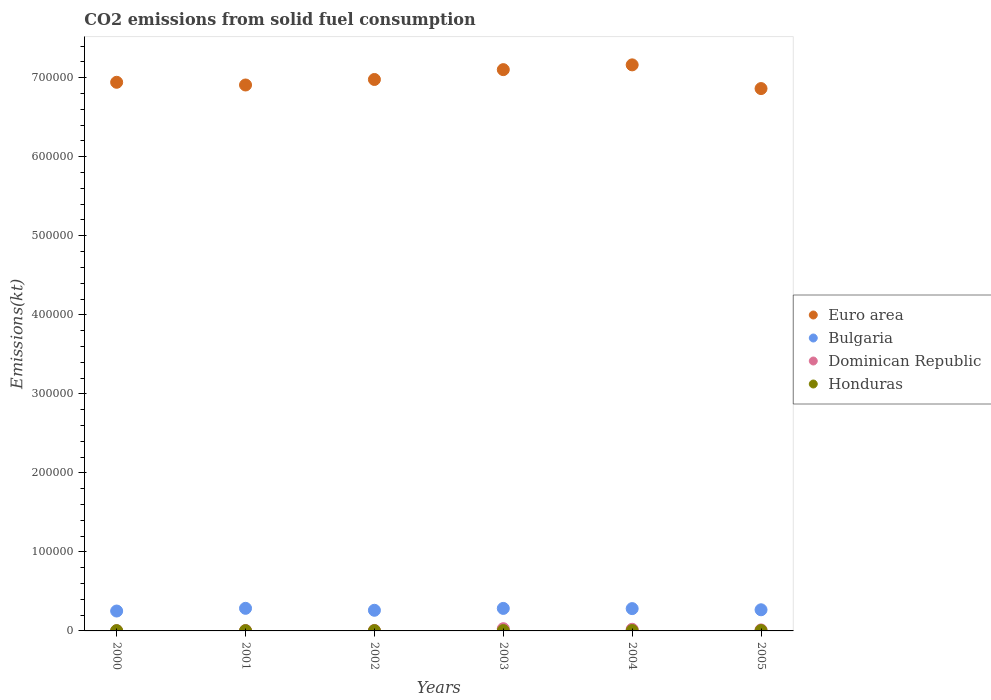What is the amount of CO2 emitted in Dominican Republic in 2000?
Provide a short and direct response. 245.69. Across all years, what is the maximum amount of CO2 emitted in Euro area?
Make the answer very short. 7.16e+05. Across all years, what is the minimum amount of CO2 emitted in Euro area?
Offer a very short reply. 6.86e+05. In which year was the amount of CO2 emitted in Dominican Republic minimum?
Offer a very short reply. 2000. What is the total amount of CO2 emitted in Bulgaria in the graph?
Ensure brevity in your answer.  1.63e+05. What is the difference between the amount of CO2 emitted in Euro area in 2000 and that in 2004?
Offer a very short reply. -2.20e+04. What is the difference between the amount of CO2 emitted in Bulgaria in 2004 and the amount of CO2 emitted in Honduras in 2001?
Offer a very short reply. 2.79e+04. What is the average amount of CO2 emitted in Honduras per year?
Make the answer very short. 409.48. In the year 2002, what is the difference between the amount of CO2 emitted in Honduras and amount of CO2 emitted in Dominican Republic?
Keep it short and to the point. -245.69. What is the ratio of the amount of CO2 emitted in Euro area in 2002 to that in 2003?
Offer a terse response. 0.98. Is the amount of CO2 emitted in Dominican Republic in 2001 less than that in 2005?
Keep it short and to the point. Yes. What is the difference between the highest and the second highest amount of CO2 emitted in Honduras?
Provide a short and direct response. 25.67. What is the difference between the highest and the lowest amount of CO2 emitted in Honduras?
Give a very brief answer. 161.35. Is the sum of the amount of CO2 emitted in Bulgaria in 2002 and 2004 greater than the maximum amount of CO2 emitted in Euro area across all years?
Give a very brief answer. No. Is it the case that in every year, the sum of the amount of CO2 emitted in Euro area and amount of CO2 emitted in Dominican Republic  is greater than the sum of amount of CO2 emitted in Bulgaria and amount of CO2 emitted in Honduras?
Your answer should be very brief. Yes. Does the amount of CO2 emitted in Bulgaria monotonically increase over the years?
Offer a very short reply. No. What is the difference between two consecutive major ticks on the Y-axis?
Make the answer very short. 1.00e+05. Are the values on the major ticks of Y-axis written in scientific E-notation?
Provide a short and direct response. No. Does the graph contain any zero values?
Your answer should be very brief. No. How many legend labels are there?
Make the answer very short. 4. What is the title of the graph?
Your answer should be very brief. CO2 emissions from solid fuel consumption. Does "United Kingdom" appear as one of the legend labels in the graph?
Ensure brevity in your answer.  No. What is the label or title of the Y-axis?
Your response must be concise. Emissions(kt). What is the Emissions(kt) of Euro area in 2000?
Provide a short and direct response. 6.94e+05. What is the Emissions(kt) of Bulgaria in 2000?
Ensure brevity in your answer.  2.52e+04. What is the Emissions(kt) of Dominican Republic in 2000?
Your answer should be compact. 245.69. What is the Emissions(kt) in Honduras in 2000?
Provide a short and direct response. 359.37. What is the Emissions(kt) of Euro area in 2001?
Offer a terse response. 6.91e+05. What is the Emissions(kt) in Bulgaria in 2001?
Offer a terse response. 2.86e+04. What is the Emissions(kt) of Dominican Republic in 2001?
Your answer should be very brief. 539.05. What is the Emissions(kt) in Honduras in 2001?
Keep it short and to the point. 326.36. What is the Emissions(kt) of Euro area in 2002?
Keep it short and to the point. 6.98e+05. What is the Emissions(kt) in Bulgaria in 2002?
Your response must be concise. 2.61e+04. What is the Emissions(kt) of Dominican Republic in 2002?
Your answer should be very brief. 619.72. What is the Emissions(kt) in Honduras in 2002?
Your answer should be compact. 374.03. What is the Emissions(kt) in Euro area in 2003?
Make the answer very short. 7.10e+05. What is the Emissions(kt) of Bulgaria in 2003?
Provide a short and direct response. 2.85e+04. What is the Emissions(kt) in Dominican Republic in 2003?
Your response must be concise. 2805.26. What is the Emissions(kt) of Honduras in 2003?
Offer a terse response. 447.37. What is the Emissions(kt) in Euro area in 2004?
Offer a very short reply. 7.16e+05. What is the Emissions(kt) of Bulgaria in 2004?
Offer a terse response. 2.82e+04. What is the Emissions(kt) in Dominican Republic in 2004?
Provide a succinct answer. 2064.52. What is the Emissions(kt) in Honduras in 2004?
Your answer should be compact. 462.04. What is the Emissions(kt) in Euro area in 2005?
Ensure brevity in your answer.  6.86e+05. What is the Emissions(kt) in Bulgaria in 2005?
Offer a terse response. 2.68e+04. What is the Emissions(kt) of Dominican Republic in 2005?
Offer a terse response. 1265.12. What is the Emissions(kt) of Honduras in 2005?
Your answer should be very brief. 487.71. Across all years, what is the maximum Emissions(kt) in Euro area?
Ensure brevity in your answer.  7.16e+05. Across all years, what is the maximum Emissions(kt) of Bulgaria?
Keep it short and to the point. 2.86e+04. Across all years, what is the maximum Emissions(kt) in Dominican Republic?
Give a very brief answer. 2805.26. Across all years, what is the maximum Emissions(kt) in Honduras?
Your answer should be compact. 487.71. Across all years, what is the minimum Emissions(kt) of Euro area?
Provide a succinct answer. 6.86e+05. Across all years, what is the minimum Emissions(kt) of Bulgaria?
Provide a short and direct response. 2.52e+04. Across all years, what is the minimum Emissions(kt) of Dominican Republic?
Give a very brief answer. 245.69. Across all years, what is the minimum Emissions(kt) of Honduras?
Make the answer very short. 326.36. What is the total Emissions(kt) in Euro area in the graph?
Provide a succinct answer. 4.20e+06. What is the total Emissions(kt) of Bulgaria in the graph?
Keep it short and to the point. 1.63e+05. What is the total Emissions(kt) of Dominican Republic in the graph?
Provide a short and direct response. 7539.35. What is the total Emissions(kt) of Honduras in the graph?
Offer a terse response. 2456.89. What is the difference between the Emissions(kt) in Euro area in 2000 and that in 2001?
Keep it short and to the point. 3419.57. What is the difference between the Emissions(kt) in Bulgaria in 2000 and that in 2001?
Provide a short and direct response. -3417.64. What is the difference between the Emissions(kt) of Dominican Republic in 2000 and that in 2001?
Ensure brevity in your answer.  -293.36. What is the difference between the Emissions(kt) in Honduras in 2000 and that in 2001?
Your answer should be very brief. 33. What is the difference between the Emissions(kt) in Euro area in 2000 and that in 2002?
Your answer should be compact. -3555.32. What is the difference between the Emissions(kt) in Bulgaria in 2000 and that in 2002?
Provide a short and direct response. -949.75. What is the difference between the Emissions(kt) in Dominican Republic in 2000 and that in 2002?
Your answer should be compact. -374.03. What is the difference between the Emissions(kt) in Honduras in 2000 and that in 2002?
Provide a short and direct response. -14.67. What is the difference between the Emissions(kt) in Euro area in 2000 and that in 2003?
Ensure brevity in your answer.  -1.60e+04. What is the difference between the Emissions(kt) of Bulgaria in 2000 and that in 2003?
Make the answer very short. -3318.64. What is the difference between the Emissions(kt) in Dominican Republic in 2000 and that in 2003?
Provide a succinct answer. -2559.57. What is the difference between the Emissions(kt) in Honduras in 2000 and that in 2003?
Your answer should be very brief. -88.01. What is the difference between the Emissions(kt) in Euro area in 2000 and that in 2004?
Your answer should be compact. -2.20e+04. What is the difference between the Emissions(kt) in Bulgaria in 2000 and that in 2004?
Your answer should be very brief. -3058.28. What is the difference between the Emissions(kt) of Dominican Republic in 2000 and that in 2004?
Make the answer very short. -1818.83. What is the difference between the Emissions(kt) of Honduras in 2000 and that in 2004?
Provide a short and direct response. -102.68. What is the difference between the Emissions(kt) of Euro area in 2000 and that in 2005?
Ensure brevity in your answer.  7950.86. What is the difference between the Emissions(kt) of Bulgaria in 2000 and that in 2005?
Provide a short and direct response. -1584.14. What is the difference between the Emissions(kt) of Dominican Republic in 2000 and that in 2005?
Make the answer very short. -1019.43. What is the difference between the Emissions(kt) of Honduras in 2000 and that in 2005?
Offer a terse response. -128.34. What is the difference between the Emissions(kt) in Euro area in 2001 and that in 2002?
Provide a short and direct response. -6974.89. What is the difference between the Emissions(kt) of Bulgaria in 2001 and that in 2002?
Your answer should be very brief. 2467.89. What is the difference between the Emissions(kt) in Dominican Republic in 2001 and that in 2002?
Provide a succinct answer. -80.67. What is the difference between the Emissions(kt) of Honduras in 2001 and that in 2002?
Make the answer very short. -47.67. What is the difference between the Emissions(kt) in Euro area in 2001 and that in 2003?
Offer a terse response. -1.94e+04. What is the difference between the Emissions(kt) in Bulgaria in 2001 and that in 2003?
Your response must be concise. 99.01. What is the difference between the Emissions(kt) in Dominican Republic in 2001 and that in 2003?
Offer a very short reply. -2266.21. What is the difference between the Emissions(kt) in Honduras in 2001 and that in 2003?
Keep it short and to the point. -121.01. What is the difference between the Emissions(kt) of Euro area in 2001 and that in 2004?
Make the answer very short. -2.55e+04. What is the difference between the Emissions(kt) in Bulgaria in 2001 and that in 2004?
Offer a very short reply. 359.37. What is the difference between the Emissions(kt) in Dominican Republic in 2001 and that in 2004?
Ensure brevity in your answer.  -1525.47. What is the difference between the Emissions(kt) of Honduras in 2001 and that in 2004?
Provide a succinct answer. -135.68. What is the difference between the Emissions(kt) in Euro area in 2001 and that in 2005?
Ensure brevity in your answer.  4531.29. What is the difference between the Emissions(kt) of Bulgaria in 2001 and that in 2005?
Offer a terse response. 1833.5. What is the difference between the Emissions(kt) in Dominican Republic in 2001 and that in 2005?
Your answer should be very brief. -726.07. What is the difference between the Emissions(kt) of Honduras in 2001 and that in 2005?
Your answer should be very brief. -161.35. What is the difference between the Emissions(kt) of Euro area in 2002 and that in 2003?
Your response must be concise. -1.24e+04. What is the difference between the Emissions(kt) in Bulgaria in 2002 and that in 2003?
Ensure brevity in your answer.  -2368.88. What is the difference between the Emissions(kt) in Dominican Republic in 2002 and that in 2003?
Provide a short and direct response. -2185.53. What is the difference between the Emissions(kt) of Honduras in 2002 and that in 2003?
Your answer should be very brief. -73.34. What is the difference between the Emissions(kt) of Euro area in 2002 and that in 2004?
Your response must be concise. -1.85e+04. What is the difference between the Emissions(kt) in Bulgaria in 2002 and that in 2004?
Give a very brief answer. -2108.53. What is the difference between the Emissions(kt) in Dominican Republic in 2002 and that in 2004?
Your answer should be very brief. -1444.8. What is the difference between the Emissions(kt) in Honduras in 2002 and that in 2004?
Provide a succinct answer. -88.01. What is the difference between the Emissions(kt) of Euro area in 2002 and that in 2005?
Give a very brief answer. 1.15e+04. What is the difference between the Emissions(kt) in Bulgaria in 2002 and that in 2005?
Make the answer very short. -634.39. What is the difference between the Emissions(kt) of Dominican Republic in 2002 and that in 2005?
Your answer should be compact. -645.39. What is the difference between the Emissions(kt) of Honduras in 2002 and that in 2005?
Offer a terse response. -113.68. What is the difference between the Emissions(kt) of Euro area in 2003 and that in 2004?
Your answer should be compact. -6039.27. What is the difference between the Emissions(kt) of Bulgaria in 2003 and that in 2004?
Offer a terse response. 260.36. What is the difference between the Emissions(kt) in Dominican Republic in 2003 and that in 2004?
Provide a short and direct response. 740.73. What is the difference between the Emissions(kt) in Honduras in 2003 and that in 2004?
Keep it short and to the point. -14.67. What is the difference between the Emissions(kt) of Euro area in 2003 and that in 2005?
Provide a short and direct response. 2.40e+04. What is the difference between the Emissions(kt) in Bulgaria in 2003 and that in 2005?
Give a very brief answer. 1734.49. What is the difference between the Emissions(kt) in Dominican Republic in 2003 and that in 2005?
Your answer should be compact. 1540.14. What is the difference between the Emissions(kt) of Honduras in 2003 and that in 2005?
Give a very brief answer. -40.34. What is the difference between the Emissions(kt) of Euro area in 2004 and that in 2005?
Provide a succinct answer. 3.00e+04. What is the difference between the Emissions(kt) in Bulgaria in 2004 and that in 2005?
Ensure brevity in your answer.  1474.13. What is the difference between the Emissions(kt) of Dominican Republic in 2004 and that in 2005?
Make the answer very short. 799.41. What is the difference between the Emissions(kt) of Honduras in 2004 and that in 2005?
Make the answer very short. -25.67. What is the difference between the Emissions(kt) of Euro area in 2000 and the Emissions(kt) of Bulgaria in 2001?
Make the answer very short. 6.66e+05. What is the difference between the Emissions(kt) of Euro area in 2000 and the Emissions(kt) of Dominican Republic in 2001?
Provide a short and direct response. 6.94e+05. What is the difference between the Emissions(kt) in Euro area in 2000 and the Emissions(kt) in Honduras in 2001?
Provide a short and direct response. 6.94e+05. What is the difference between the Emissions(kt) of Bulgaria in 2000 and the Emissions(kt) of Dominican Republic in 2001?
Offer a terse response. 2.46e+04. What is the difference between the Emissions(kt) of Bulgaria in 2000 and the Emissions(kt) of Honduras in 2001?
Provide a succinct answer. 2.48e+04. What is the difference between the Emissions(kt) in Dominican Republic in 2000 and the Emissions(kt) in Honduras in 2001?
Ensure brevity in your answer.  -80.67. What is the difference between the Emissions(kt) of Euro area in 2000 and the Emissions(kt) of Bulgaria in 2002?
Your answer should be compact. 6.68e+05. What is the difference between the Emissions(kt) of Euro area in 2000 and the Emissions(kt) of Dominican Republic in 2002?
Offer a very short reply. 6.94e+05. What is the difference between the Emissions(kt) of Euro area in 2000 and the Emissions(kt) of Honduras in 2002?
Provide a short and direct response. 6.94e+05. What is the difference between the Emissions(kt) of Bulgaria in 2000 and the Emissions(kt) of Dominican Republic in 2002?
Your answer should be compact. 2.46e+04. What is the difference between the Emissions(kt) in Bulgaria in 2000 and the Emissions(kt) in Honduras in 2002?
Provide a succinct answer. 2.48e+04. What is the difference between the Emissions(kt) of Dominican Republic in 2000 and the Emissions(kt) of Honduras in 2002?
Keep it short and to the point. -128.34. What is the difference between the Emissions(kt) in Euro area in 2000 and the Emissions(kt) in Bulgaria in 2003?
Offer a terse response. 6.66e+05. What is the difference between the Emissions(kt) in Euro area in 2000 and the Emissions(kt) in Dominican Republic in 2003?
Keep it short and to the point. 6.91e+05. What is the difference between the Emissions(kt) of Euro area in 2000 and the Emissions(kt) of Honduras in 2003?
Give a very brief answer. 6.94e+05. What is the difference between the Emissions(kt) in Bulgaria in 2000 and the Emissions(kt) in Dominican Republic in 2003?
Give a very brief answer. 2.24e+04. What is the difference between the Emissions(kt) of Bulgaria in 2000 and the Emissions(kt) of Honduras in 2003?
Provide a succinct answer. 2.47e+04. What is the difference between the Emissions(kt) of Dominican Republic in 2000 and the Emissions(kt) of Honduras in 2003?
Provide a succinct answer. -201.69. What is the difference between the Emissions(kt) in Euro area in 2000 and the Emissions(kt) in Bulgaria in 2004?
Your answer should be very brief. 6.66e+05. What is the difference between the Emissions(kt) of Euro area in 2000 and the Emissions(kt) of Dominican Republic in 2004?
Give a very brief answer. 6.92e+05. What is the difference between the Emissions(kt) of Euro area in 2000 and the Emissions(kt) of Honduras in 2004?
Provide a succinct answer. 6.94e+05. What is the difference between the Emissions(kt) in Bulgaria in 2000 and the Emissions(kt) in Dominican Republic in 2004?
Give a very brief answer. 2.31e+04. What is the difference between the Emissions(kt) in Bulgaria in 2000 and the Emissions(kt) in Honduras in 2004?
Offer a very short reply. 2.47e+04. What is the difference between the Emissions(kt) in Dominican Republic in 2000 and the Emissions(kt) in Honduras in 2004?
Give a very brief answer. -216.35. What is the difference between the Emissions(kt) of Euro area in 2000 and the Emissions(kt) of Bulgaria in 2005?
Make the answer very short. 6.68e+05. What is the difference between the Emissions(kt) in Euro area in 2000 and the Emissions(kt) in Dominican Republic in 2005?
Ensure brevity in your answer.  6.93e+05. What is the difference between the Emissions(kt) of Euro area in 2000 and the Emissions(kt) of Honduras in 2005?
Keep it short and to the point. 6.94e+05. What is the difference between the Emissions(kt) in Bulgaria in 2000 and the Emissions(kt) in Dominican Republic in 2005?
Keep it short and to the point. 2.39e+04. What is the difference between the Emissions(kt) of Bulgaria in 2000 and the Emissions(kt) of Honduras in 2005?
Keep it short and to the point. 2.47e+04. What is the difference between the Emissions(kt) in Dominican Republic in 2000 and the Emissions(kt) in Honduras in 2005?
Offer a very short reply. -242.02. What is the difference between the Emissions(kt) in Euro area in 2001 and the Emissions(kt) in Bulgaria in 2002?
Your answer should be very brief. 6.65e+05. What is the difference between the Emissions(kt) in Euro area in 2001 and the Emissions(kt) in Dominican Republic in 2002?
Keep it short and to the point. 6.90e+05. What is the difference between the Emissions(kt) of Euro area in 2001 and the Emissions(kt) of Honduras in 2002?
Offer a very short reply. 6.90e+05. What is the difference between the Emissions(kt) in Bulgaria in 2001 and the Emissions(kt) in Dominican Republic in 2002?
Your answer should be very brief. 2.80e+04. What is the difference between the Emissions(kt) in Bulgaria in 2001 and the Emissions(kt) in Honduras in 2002?
Offer a terse response. 2.82e+04. What is the difference between the Emissions(kt) in Dominican Republic in 2001 and the Emissions(kt) in Honduras in 2002?
Provide a short and direct response. 165.01. What is the difference between the Emissions(kt) of Euro area in 2001 and the Emissions(kt) of Bulgaria in 2003?
Provide a short and direct response. 6.62e+05. What is the difference between the Emissions(kt) of Euro area in 2001 and the Emissions(kt) of Dominican Republic in 2003?
Keep it short and to the point. 6.88e+05. What is the difference between the Emissions(kt) in Euro area in 2001 and the Emissions(kt) in Honduras in 2003?
Your answer should be compact. 6.90e+05. What is the difference between the Emissions(kt) of Bulgaria in 2001 and the Emissions(kt) of Dominican Republic in 2003?
Give a very brief answer. 2.58e+04. What is the difference between the Emissions(kt) in Bulgaria in 2001 and the Emissions(kt) in Honduras in 2003?
Offer a very short reply. 2.81e+04. What is the difference between the Emissions(kt) in Dominican Republic in 2001 and the Emissions(kt) in Honduras in 2003?
Your answer should be compact. 91.67. What is the difference between the Emissions(kt) of Euro area in 2001 and the Emissions(kt) of Bulgaria in 2004?
Provide a short and direct response. 6.63e+05. What is the difference between the Emissions(kt) of Euro area in 2001 and the Emissions(kt) of Dominican Republic in 2004?
Your answer should be very brief. 6.89e+05. What is the difference between the Emissions(kt) of Euro area in 2001 and the Emissions(kt) of Honduras in 2004?
Offer a terse response. 6.90e+05. What is the difference between the Emissions(kt) in Bulgaria in 2001 and the Emissions(kt) in Dominican Republic in 2004?
Your answer should be compact. 2.65e+04. What is the difference between the Emissions(kt) in Bulgaria in 2001 and the Emissions(kt) in Honduras in 2004?
Your response must be concise. 2.81e+04. What is the difference between the Emissions(kt) of Dominican Republic in 2001 and the Emissions(kt) of Honduras in 2004?
Your answer should be compact. 77.01. What is the difference between the Emissions(kt) of Euro area in 2001 and the Emissions(kt) of Bulgaria in 2005?
Your answer should be very brief. 6.64e+05. What is the difference between the Emissions(kt) of Euro area in 2001 and the Emissions(kt) of Dominican Republic in 2005?
Your answer should be very brief. 6.90e+05. What is the difference between the Emissions(kt) in Euro area in 2001 and the Emissions(kt) in Honduras in 2005?
Make the answer very short. 6.90e+05. What is the difference between the Emissions(kt) in Bulgaria in 2001 and the Emissions(kt) in Dominican Republic in 2005?
Offer a terse response. 2.73e+04. What is the difference between the Emissions(kt) in Bulgaria in 2001 and the Emissions(kt) in Honduras in 2005?
Offer a very short reply. 2.81e+04. What is the difference between the Emissions(kt) in Dominican Republic in 2001 and the Emissions(kt) in Honduras in 2005?
Make the answer very short. 51.34. What is the difference between the Emissions(kt) in Euro area in 2002 and the Emissions(kt) in Bulgaria in 2003?
Ensure brevity in your answer.  6.69e+05. What is the difference between the Emissions(kt) of Euro area in 2002 and the Emissions(kt) of Dominican Republic in 2003?
Ensure brevity in your answer.  6.95e+05. What is the difference between the Emissions(kt) in Euro area in 2002 and the Emissions(kt) in Honduras in 2003?
Give a very brief answer. 6.97e+05. What is the difference between the Emissions(kt) in Bulgaria in 2002 and the Emissions(kt) in Dominican Republic in 2003?
Provide a short and direct response. 2.33e+04. What is the difference between the Emissions(kt) of Bulgaria in 2002 and the Emissions(kt) of Honduras in 2003?
Your response must be concise. 2.57e+04. What is the difference between the Emissions(kt) of Dominican Republic in 2002 and the Emissions(kt) of Honduras in 2003?
Offer a terse response. 172.35. What is the difference between the Emissions(kt) of Euro area in 2002 and the Emissions(kt) of Bulgaria in 2004?
Your answer should be very brief. 6.70e+05. What is the difference between the Emissions(kt) of Euro area in 2002 and the Emissions(kt) of Dominican Republic in 2004?
Make the answer very short. 6.96e+05. What is the difference between the Emissions(kt) of Euro area in 2002 and the Emissions(kt) of Honduras in 2004?
Offer a very short reply. 6.97e+05. What is the difference between the Emissions(kt) of Bulgaria in 2002 and the Emissions(kt) of Dominican Republic in 2004?
Offer a very short reply. 2.41e+04. What is the difference between the Emissions(kt) in Bulgaria in 2002 and the Emissions(kt) in Honduras in 2004?
Give a very brief answer. 2.57e+04. What is the difference between the Emissions(kt) of Dominican Republic in 2002 and the Emissions(kt) of Honduras in 2004?
Ensure brevity in your answer.  157.68. What is the difference between the Emissions(kt) of Euro area in 2002 and the Emissions(kt) of Bulgaria in 2005?
Your answer should be compact. 6.71e+05. What is the difference between the Emissions(kt) in Euro area in 2002 and the Emissions(kt) in Dominican Republic in 2005?
Offer a terse response. 6.97e+05. What is the difference between the Emissions(kt) in Euro area in 2002 and the Emissions(kt) in Honduras in 2005?
Offer a terse response. 6.97e+05. What is the difference between the Emissions(kt) in Bulgaria in 2002 and the Emissions(kt) in Dominican Republic in 2005?
Make the answer very short. 2.49e+04. What is the difference between the Emissions(kt) in Bulgaria in 2002 and the Emissions(kt) in Honduras in 2005?
Give a very brief answer. 2.56e+04. What is the difference between the Emissions(kt) in Dominican Republic in 2002 and the Emissions(kt) in Honduras in 2005?
Your answer should be compact. 132.01. What is the difference between the Emissions(kt) of Euro area in 2003 and the Emissions(kt) of Bulgaria in 2004?
Keep it short and to the point. 6.82e+05. What is the difference between the Emissions(kt) of Euro area in 2003 and the Emissions(kt) of Dominican Republic in 2004?
Make the answer very short. 7.08e+05. What is the difference between the Emissions(kt) of Euro area in 2003 and the Emissions(kt) of Honduras in 2004?
Make the answer very short. 7.10e+05. What is the difference between the Emissions(kt) in Bulgaria in 2003 and the Emissions(kt) in Dominican Republic in 2004?
Offer a terse response. 2.64e+04. What is the difference between the Emissions(kt) in Bulgaria in 2003 and the Emissions(kt) in Honduras in 2004?
Your response must be concise. 2.80e+04. What is the difference between the Emissions(kt) of Dominican Republic in 2003 and the Emissions(kt) of Honduras in 2004?
Ensure brevity in your answer.  2343.21. What is the difference between the Emissions(kt) of Euro area in 2003 and the Emissions(kt) of Bulgaria in 2005?
Offer a terse response. 6.84e+05. What is the difference between the Emissions(kt) of Euro area in 2003 and the Emissions(kt) of Dominican Republic in 2005?
Your answer should be compact. 7.09e+05. What is the difference between the Emissions(kt) of Euro area in 2003 and the Emissions(kt) of Honduras in 2005?
Offer a very short reply. 7.10e+05. What is the difference between the Emissions(kt) in Bulgaria in 2003 and the Emissions(kt) in Dominican Republic in 2005?
Provide a short and direct response. 2.72e+04. What is the difference between the Emissions(kt) of Bulgaria in 2003 and the Emissions(kt) of Honduras in 2005?
Make the answer very short. 2.80e+04. What is the difference between the Emissions(kt) of Dominican Republic in 2003 and the Emissions(kt) of Honduras in 2005?
Give a very brief answer. 2317.54. What is the difference between the Emissions(kt) of Euro area in 2004 and the Emissions(kt) of Bulgaria in 2005?
Keep it short and to the point. 6.90e+05. What is the difference between the Emissions(kt) of Euro area in 2004 and the Emissions(kt) of Dominican Republic in 2005?
Give a very brief answer. 7.15e+05. What is the difference between the Emissions(kt) in Euro area in 2004 and the Emissions(kt) in Honduras in 2005?
Provide a short and direct response. 7.16e+05. What is the difference between the Emissions(kt) in Bulgaria in 2004 and the Emissions(kt) in Dominican Republic in 2005?
Offer a very short reply. 2.70e+04. What is the difference between the Emissions(kt) in Bulgaria in 2004 and the Emissions(kt) in Honduras in 2005?
Give a very brief answer. 2.77e+04. What is the difference between the Emissions(kt) of Dominican Republic in 2004 and the Emissions(kt) of Honduras in 2005?
Provide a short and direct response. 1576.81. What is the average Emissions(kt) of Euro area per year?
Offer a very short reply. 6.99e+05. What is the average Emissions(kt) of Bulgaria per year?
Offer a terse response. 2.72e+04. What is the average Emissions(kt) in Dominican Republic per year?
Make the answer very short. 1256.56. What is the average Emissions(kt) in Honduras per year?
Offer a very short reply. 409.48. In the year 2000, what is the difference between the Emissions(kt) of Euro area and Emissions(kt) of Bulgaria?
Ensure brevity in your answer.  6.69e+05. In the year 2000, what is the difference between the Emissions(kt) in Euro area and Emissions(kt) in Dominican Republic?
Offer a very short reply. 6.94e+05. In the year 2000, what is the difference between the Emissions(kt) of Euro area and Emissions(kt) of Honduras?
Make the answer very short. 6.94e+05. In the year 2000, what is the difference between the Emissions(kt) in Bulgaria and Emissions(kt) in Dominican Republic?
Provide a short and direct response. 2.49e+04. In the year 2000, what is the difference between the Emissions(kt) of Bulgaria and Emissions(kt) of Honduras?
Make the answer very short. 2.48e+04. In the year 2000, what is the difference between the Emissions(kt) in Dominican Republic and Emissions(kt) in Honduras?
Offer a terse response. -113.68. In the year 2001, what is the difference between the Emissions(kt) in Euro area and Emissions(kt) in Bulgaria?
Your response must be concise. 6.62e+05. In the year 2001, what is the difference between the Emissions(kt) in Euro area and Emissions(kt) in Dominican Republic?
Your response must be concise. 6.90e+05. In the year 2001, what is the difference between the Emissions(kt) of Euro area and Emissions(kt) of Honduras?
Give a very brief answer. 6.91e+05. In the year 2001, what is the difference between the Emissions(kt) in Bulgaria and Emissions(kt) in Dominican Republic?
Your response must be concise. 2.80e+04. In the year 2001, what is the difference between the Emissions(kt) of Bulgaria and Emissions(kt) of Honduras?
Your answer should be compact. 2.83e+04. In the year 2001, what is the difference between the Emissions(kt) in Dominican Republic and Emissions(kt) in Honduras?
Offer a terse response. 212.69. In the year 2002, what is the difference between the Emissions(kt) in Euro area and Emissions(kt) in Bulgaria?
Your answer should be very brief. 6.72e+05. In the year 2002, what is the difference between the Emissions(kt) in Euro area and Emissions(kt) in Dominican Republic?
Provide a short and direct response. 6.97e+05. In the year 2002, what is the difference between the Emissions(kt) in Euro area and Emissions(kt) in Honduras?
Your answer should be compact. 6.97e+05. In the year 2002, what is the difference between the Emissions(kt) in Bulgaria and Emissions(kt) in Dominican Republic?
Keep it short and to the point. 2.55e+04. In the year 2002, what is the difference between the Emissions(kt) of Bulgaria and Emissions(kt) of Honduras?
Your answer should be compact. 2.57e+04. In the year 2002, what is the difference between the Emissions(kt) in Dominican Republic and Emissions(kt) in Honduras?
Give a very brief answer. 245.69. In the year 2003, what is the difference between the Emissions(kt) in Euro area and Emissions(kt) in Bulgaria?
Provide a succinct answer. 6.82e+05. In the year 2003, what is the difference between the Emissions(kt) in Euro area and Emissions(kt) in Dominican Republic?
Provide a succinct answer. 7.07e+05. In the year 2003, what is the difference between the Emissions(kt) of Euro area and Emissions(kt) of Honduras?
Ensure brevity in your answer.  7.10e+05. In the year 2003, what is the difference between the Emissions(kt) in Bulgaria and Emissions(kt) in Dominican Republic?
Your answer should be compact. 2.57e+04. In the year 2003, what is the difference between the Emissions(kt) of Bulgaria and Emissions(kt) of Honduras?
Make the answer very short. 2.80e+04. In the year 2003, what is the difference between the Emissions(kt) of Dominican Republic and Emissions(kt) of Honduras?
Offer a very short reply. 2357.88. In the year 2004, what is the difference between the Emissions(kt) of Euro area and Emissions(kt) of Bulgaria?
Make the answer very short. 6.88e+05. In the year 2004, what is the difference between the Emissions(kt) in Euro area and Emissions(kt) in Dominican Republic?
Provide a succinct answer. 7.14e+05. In the year 2004, what is the difference between the Emissions(kt) in Euro area and Emissions(kt) in Honduras?
Make the answer very short. 7.16e+05. In the year 2004, what is the difference between the Emissions(kt) of Bulgaria and Emissions(kt) of Dominican Republic?
Offer a terse response. 2.62e+04. In the year 2004, what is the difference between the Emissions(kt) in Bulgaria and Emissions(kt) in Honduras?
Offer a very short reply. 2.78e+04. In the year 2004, what is the difference between the Emissions(kt) of Dominican Republic and Emissions(kt) of Honduras?
Your response must be concise. 1602.48. In the year 2005, what is the difference between the Emissions(kt) of Euro area and Emissions(kt) of Bulgaria?
Offer a terse response. 6.60e+05. In the year 2005, what is the difference between the Emissions(kt) in Euro area and Emissions(kt) in Dominican Republic?
Your answer should be very brief. 6.85e+05. In the year 2005, what is the difference between the Emissions(kt) of Euro area and Emissions(kt) of Honduras?
Offer a very short reply. 6.86e+05. In the year 2005, what is the difference between the Emissions(kt) of Bulgaria and Emissions(kt) of Dominican Republic?
Provide a short and direct response. 2.55e+04. In the year 2005, what is the difference between the Emissions(kt) of Bulgaria and Emissions(kt) of Honduras?
Provide a succinct answer. 2.63e+04. In the year 2005, what is the difference between the Emissions(kt) of Dominican Republic and Emissions(kt) of Honduras?
Offer a terse response. 777.4. What is the ratio of the Emissions(kt) in Bulgaria in 2000 to that in 2001?
Provide a succinct answer. 0.88. What is the ratio of the Emissions(kt) in Dominican Republic in 2000 to that in 2001?
Provide a short and direct response. 0.46. What is the ratio of the Emissions(kt) in Honduras in 2000 to that in 2001?
Keep it short and to the point. 1.1. What is the ratio of the Emissions(kt) in Euro area in 2000 to that in 2002?
Your answer should be very brief. 0.99. What is the ratio of the Emissions(kt) of Bulgaria in 2000 to that in 2002?
Offer a terse response. 0.96. What is the ratio of the Emissions(kt) of Dominican Republic in 2000 to that in 2002?
Make the answer very short. 0.4. What is the ratio of the Emissions(kt) in Honduras in 2000 to that in 2002?
Give a very brief answer. 0.96. What is the ratio of the Emissions(kt) in Euro area in 2000 to that in 2003?
Your answer should be compact. 0.98. What is the ratio of the Emissions(kt) of Bulgaria in 2000 to that in 2003?
Provide a short and direct response. 0.88. What is the ratio of the Emissions(kt) in Dominican Republic in 2000 to that in 2003?
Ensure brevity in your answer.  0.09. What is the ratio of the Emissions(kt) in Honduras in 2000 to that in 2003?
Your response must be concise. 0.8. What is the ratio of the Emissions(kt) in Euro area in 2000 to that in 2004?
Your response must be concise. 0.97. What is the ratio of the Emissions(kt) of Bulgaria in 2000 to that in 2004?
Your response must be concise. 0.89. What is the ratio of the Emissions(kt) in Dominican Republic in 2000 to that in 2004?
Offer a very short reply. 0.12. What is the ratio of the Emissions(kt) of Honduras in 2000 to that in 2004?
Your response must be concise. 0.78. What is the ratio of the Emissions(kt) of Euro area in 2000 to that in 2005?
Your response must be concise. 1.01. What is the ratio of the Emissions(kt) in Bulgaria in 2000 to that in 2005?
Ensure brevity in your answer.  0.94. What is the ratio of the Emissions(kt) of Dominican Republic in 2000 to that in 2005?
Your response must be concise. 0.19. What is the ratio of the Emissions(kt) in Honduras in 2000 to that in 2005?
Provide a short and direct response. 0.74. What is the ratio of the Emissions(kt) of Euro area in 2001 to that in 2002?
Your answer should be very brief. 0.99. What is the ratio of the Emissions(kt) of Bulgaria in 2001 to that in 2002?
Make the answer very short. 1.09. What is the ratio of the Emissions(kt) in Dominican Republic in 2001 to that in 2002?
Offer a terse response. 0.87. What is the ratio of the Emissions(kt) in Honduras in 2001 to that in 2002?
Keep it short and to the point. 0.87. What is the ratio of the Emissions(kt) of Euro area in 2001 to that in 2003?
Provide a short and direct response. 0.97. What is the ratio of the Emissions(kt) in Dominican Republic in 2001 to that in 2003?
Your answer should be very brief. 0.19. What is the ratio of the Emissions(kt) of Honduras in 2001 to that in 2003?
Keep it short and to the point. 0.73. What is the ratio of the Emissions(kt) in Euro area in 2001 to that in 2004?
Offer a very short reply. 0.96. What is the ratio of the Emissions(kt) in Bulgaria in 2001 to that in 2004?
Provide a short and direct response. 1.01. What is the ratio of the Emissions(kt) of Dominican Republic in 2001 to that in 2004?
Offer a very short reply. 0.26. What is the ratio of the Emissions(kt) of Honduras in 2001 to that in 2004?
Offer a terse response. 0.71. What is the ratio of the Emissions(kt) in Euro area in 2001 to that in 2005?
Your answer should be very brief. 1.01. What is the ratio of the Emissions(kt) in Bulgaria in 2001 to that in 2005?
Your response must be concise. 1.07. What is the ratio of the Emissions(kt) in Dominican Republic in 2001 to that in 2005?
Make the answer very short. 0.43. What is the ratio of the Emissions(kt) in Honduras in 2001 to that in 2005?
Your response must be concise. 0.67. What is the ratio of the Emissions(kt) of Euro area in 2002 to that in 2003?
Provide a short and direct response. 0.98. What is the ratio of the Emissions(kt) of Bulgaria in 2002 to that in 2003?
Your answer should be compact. 0.92. What is the ratio of the Emissions(kt) of Dominican Republic in 2002 to that in 2003?
Offer a very short reply. 0.22. What is the ratio of the Emissions(kt) of Honduras in 2002 to that in 2003?
Provide a succinct answer. 0.84. What is the ratio of the Emissions(kt) of Euro area in 2002 to that in 2004?
Ensure brevity in your answer.  0.97. What is the ratio of the Emissions(kt) in Bulgaria in 2002 to that in 2004?
Provide a succinct answer. 0.93. What is the ratio of the Emissions(kt) in Dominican Republic in 2002 to that in 2004?
Make the answer very short. 0.3. What is the ratio of the Emissions(kt) in Honduras in 2002 to that in 2004?
Provide a short and direct response. 0.81. What is the ratio of the Emissions(kt) in Euro area in 2002 to that in 2005?
Give a very brief answer. 1.02. What is the ratio of the Emissions(kt) in Bulgaria in 2002 to that in 2005?
Your answer should be very brief. 0.98. What is the ratio of the Emissions(kt) in Dominican Republic in 2002 to that in 2005?
Offer a terse response. 0.49. What is the ratio of the Emissions(kt) of Honduras in 2002 to that in 2005?
Your answer should be compact. 0.77. What is the ratio of the Emissions(kt) in Euro area in 2003 to that in 2004?
Provide a short and direct response. 0.99. What is the ratio of the Emissions(kt) in Bulgaria in 2003 to that in 2004?
Make the answer very short. 1.01. What is the ratio of the Emissions(kt) of Dominican Republic in 2003 to that in 2004?
Provide a succinct answer. 1.36. What is the ratio of the Emissions(kt) in Honduras in 2003 to that in 2004?
Your answer should be compact. 0.97. What is the ratio of the Emissions(kt) of Euro area in 2003 to that in 2005?
Offer a very short reply. 1.03. What is the ratio of the Emissions(kt) in Bulgaria in 2003 to that in 2005?
Ensure brevity in your answer.  1.06. What is the ratio of the Emissions(kt) in Dominican Republic in 2003 to that in 2005?
Your answer should be compact. 2.22. What is the ratio of the Emissions(kt) in Honduras in 2003 to that in 2005?
Offer a very short reply. 0.92. What is the ratio of the Emissions(kt) of Euro area in 2004 to that in 2005?
Ensure brevity in your answer.  1.04. What is the ratio of the Emissions(kt) of Bulgaria in 2004 to that in 2005?
Ensure brevity in your answer.  1.06. What is the ratio of the Emissions(kt) in Dominican Republic in 2004 to that in 2005?
Ensure brevity in your answer.  1.63. What is the difference between the highest and the second highest Emissions(kt) of Euro area?
Provide a succinct answer. 6039.27. What is the difference between the highest and the second highest Emissions(kt) of Bulgaria?
Keep it short and to the point. 99.01. What is the difference between the highest and the second highest Emissions(kt) in Dominican Republic?
Your answer should be very brief. 740.73. What is the difference between the highest and the second highest Emissions(kt) in Honduras?
Your answer should be compact. 25.67. What is the difference between the highest and the lowest Emissions(kt) of Euro area?
Your answer should be very brief. 3.00e+04. What is the difference between the highest and the lowest Emissions(kt) in Bulgaria?
Make the answer very short. 3417.64. What is the difference between the highest and the lowest Emissions(kt) of Dominican Republic?
Give a very brief answer. 2559.57. What is the difference between the highest and the lowest Emissions(kt) of Honduras?
Make the answer very short. 161.35. 